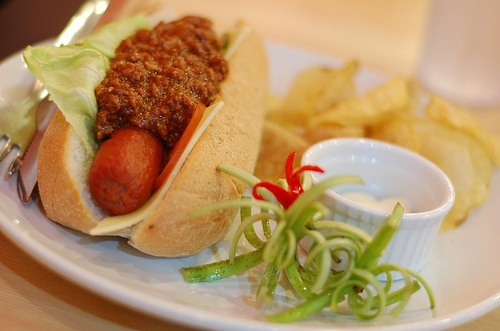Describe the objects in this image and their specific colors. I can see hot dog in black, tan, red, and maroon tones, bowl in black, lightgray, tan, olive, and darkgray tones, cup in black, lightgray, tan, and darkgray tones, cup in tan and black tones, and carrot in black, maroon, and brown tones in this image. 